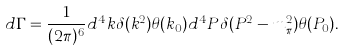Convert formula to latex. <formula><loc_0><loc_0><loc_500><loc_500>d \Gamma = \frac { 1 } { ( 2 \pi ) ^ { 6 } } d ^ { 4 } k \delta ( k ^ { 2 } ) \theta ( k _ { 0 } ) d ^ { 4 } P \delta ( P ^ { 2 } - m _ { \pi } ^ { 2 } ) \theta ( P _ { 0 } ) .</formula> 